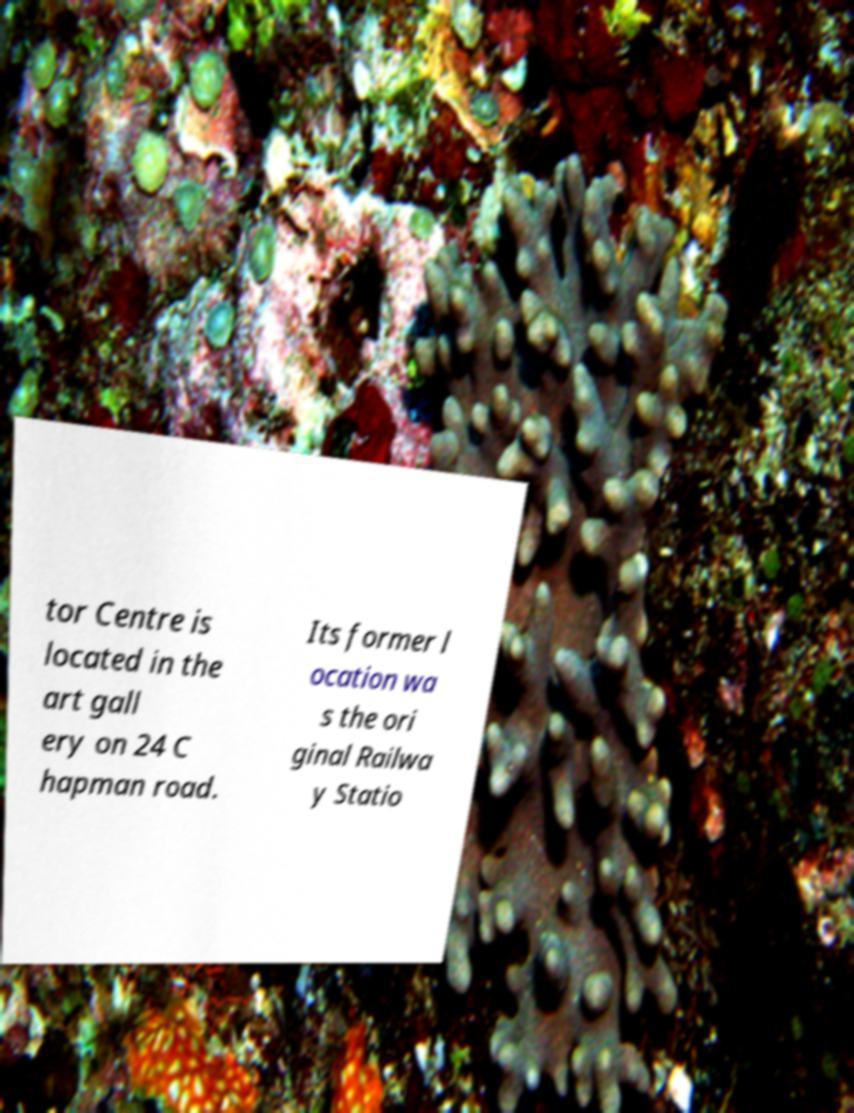Could you assist in decoding the text presented in this image and type it out clearly? tor Centre is located in the art gall ery on 24 C hapman road. Its former l ocation wa s the ori ginal Railwa y Statio 